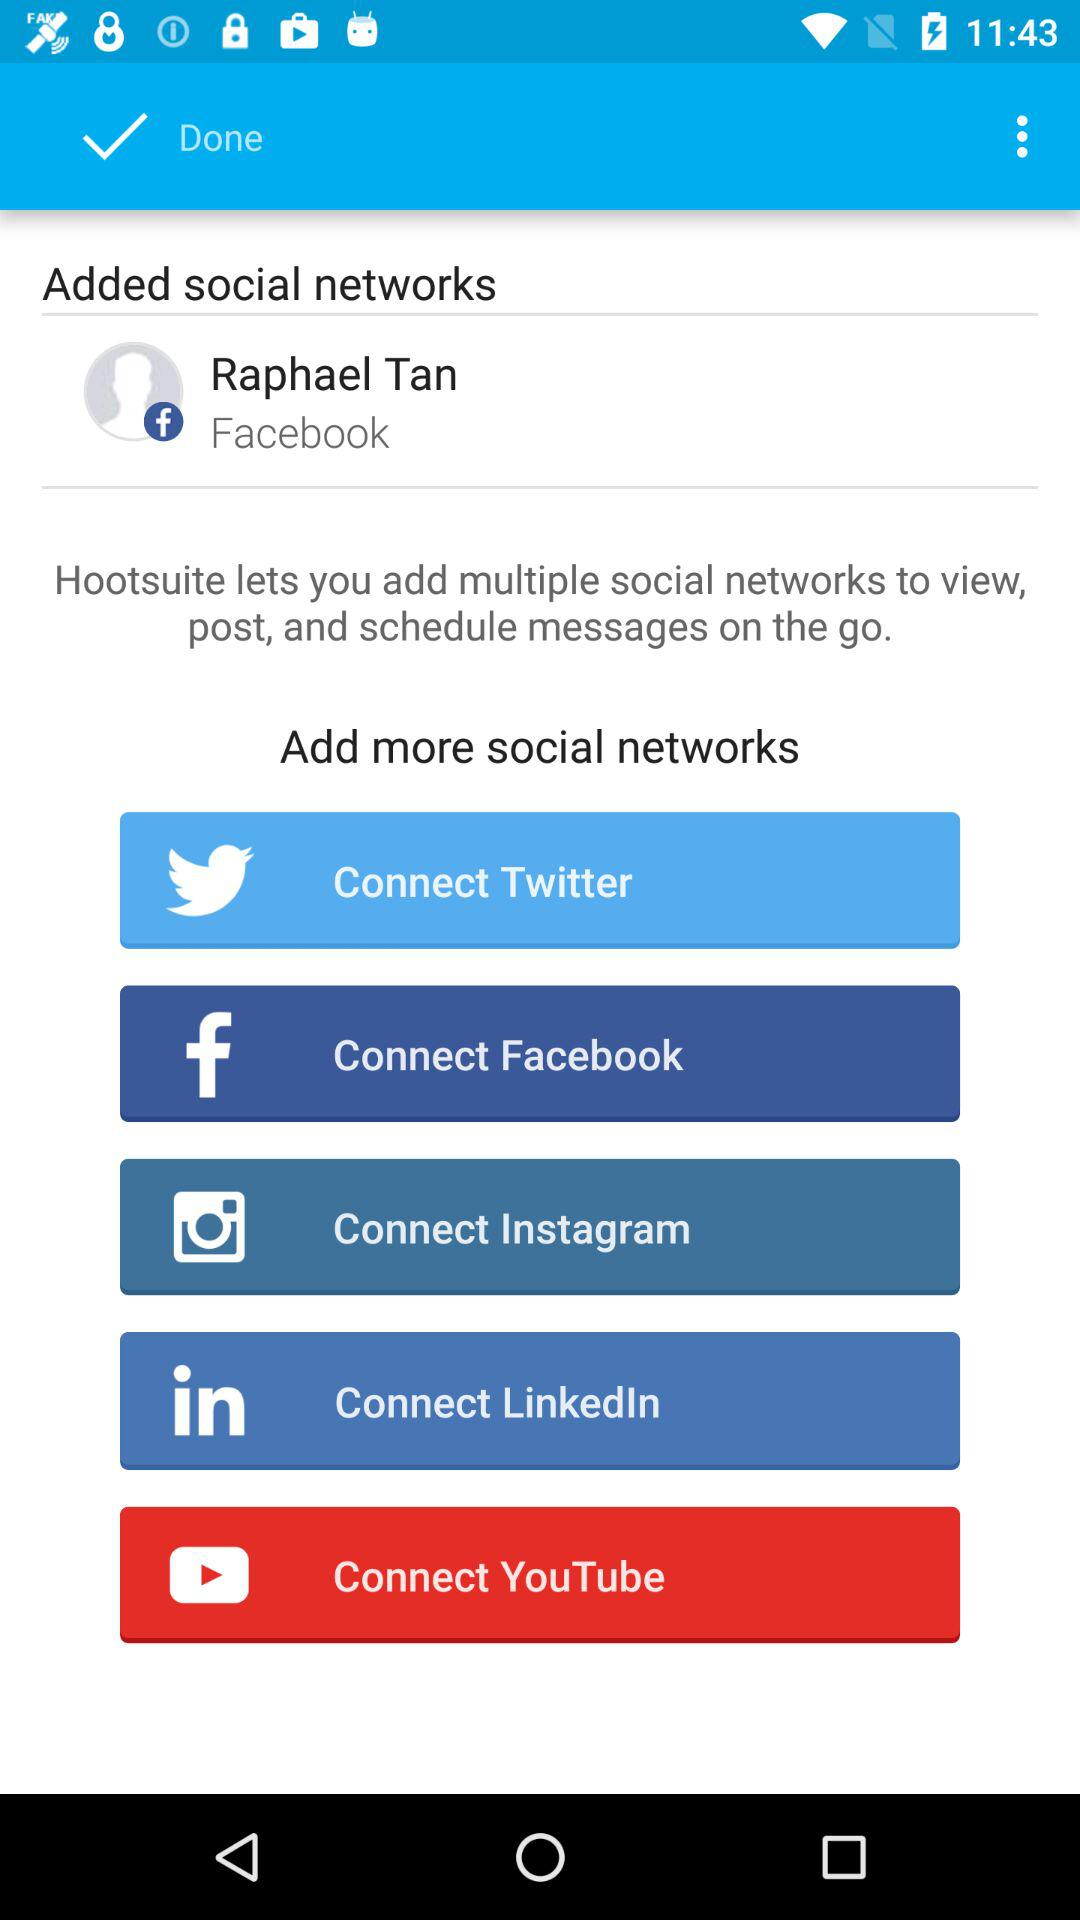How many social networks can be connected?
Answer the question using a single word or phrase. 5 